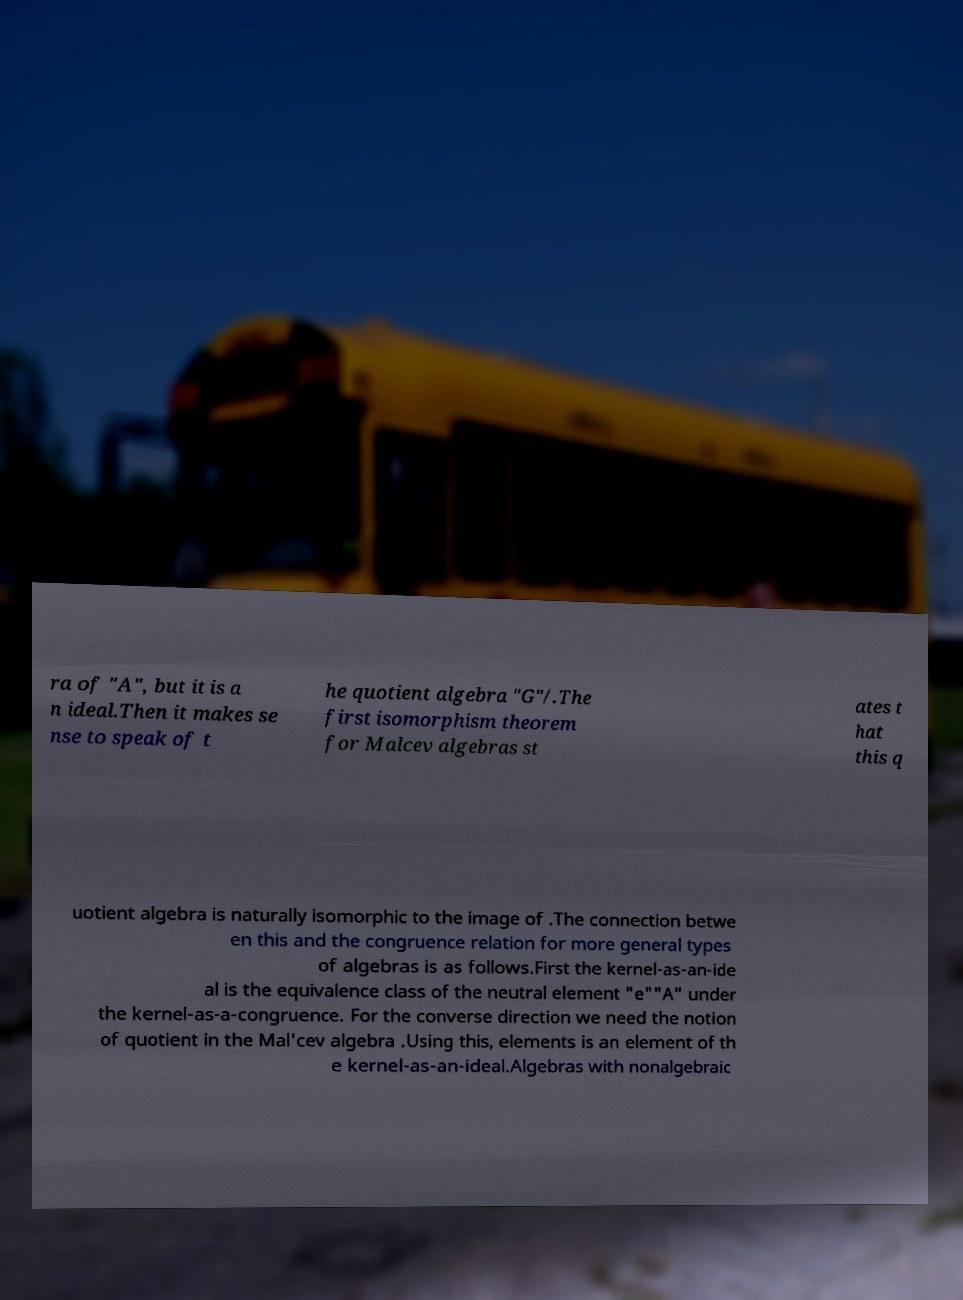I need the written content from this picture converted into text. Can you do that? ra of "A", but it is a n ideal.Then it makes se nse to speak of t he quotient algebra "G"/.The first isomorphism theorem for Malcev algebras st ates t hat this q uotient algebra is naturally isomorphic to the image of .The connection betwe en this and the congruence relation for more general types of algebras is as follows.First the kernel-as-an-ide al is the equivalence class of the neutral element "e""A" under the kernel-as-a-congruence. For the converse direction we need the notion of quotient in the Mal'cev algebra .Using this, elements is an element of th e kernel-as-an-ideal.Algebras with nonalgebraic 